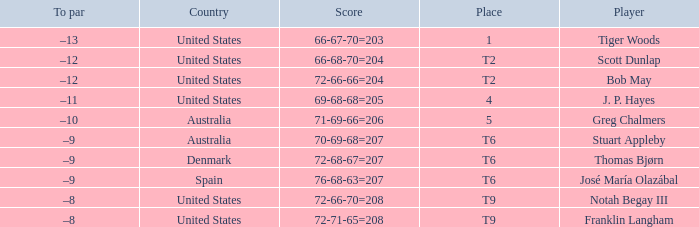What is the place of the player with a 72-71-65=208 score? T9. 